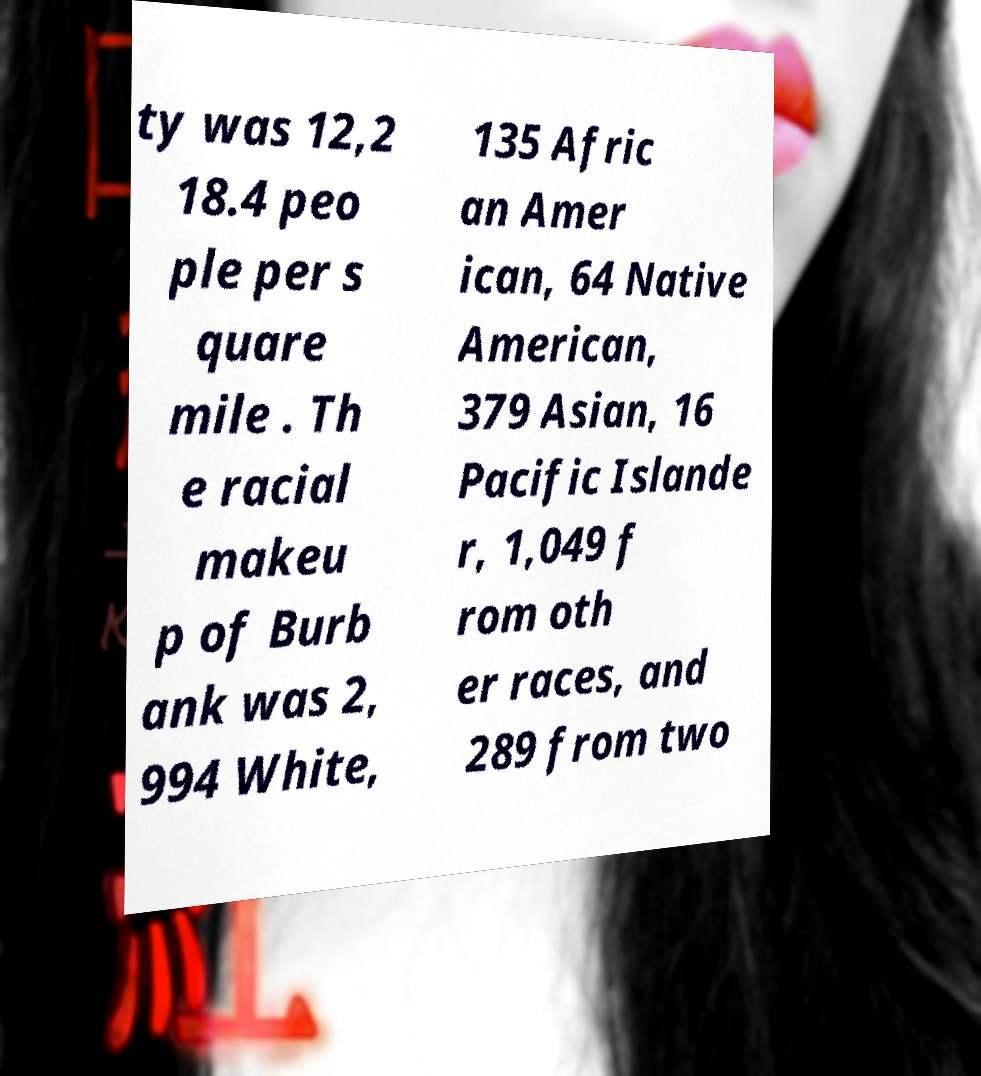There's text embedded in this image that I need extracted. Can you transcribe it verbatim? ty was 12,2 18.4 peo ple per s quare mile . Th e racial makeu p of Burb ank was 2, 994 White, 135 Afric an Amer ican, 64 Native American, 379 Asian, 16 Pacific Islande r, 1,049 f rom oth er races, and 289 from two 